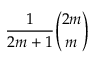<formula> <loc_0><loc_0><loc_500><loc_500>{ \frac { 1 } { 2 m + 1 } } { \binom { 2 m } { m } }</formula> 